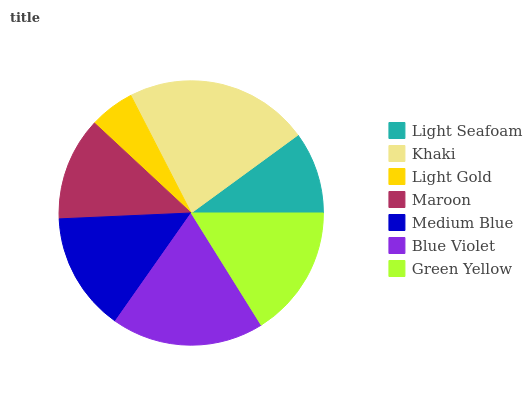Is Light Gold the minimum?
Answer yes or no. Yes. Is Khaki the maximum?
Answer yes or no. Yes. Is Khaki the minimum?
Answer yes or no. No. Is Light Gold the maximum?
Answer yes or no. No. Is Khaki greater than Light Gold?
Answer yes or no. Yes. Is Light Gold less than Khaki?
Answer yes or no. Yes. Is Light Gold greater than Khaki?
Answer yes or no. No. Is Khaki less than Light Gold?
Answer yes or no. No. Is Medium Blue the high median?
Answer yes or no. Yes. Is Medium Blue the low median?
Answer yes or no. Yes. Is Green Yellow the high median?
Answer yes or no. No. Is Blue Violet the low median?
Answer yes or no. No. 